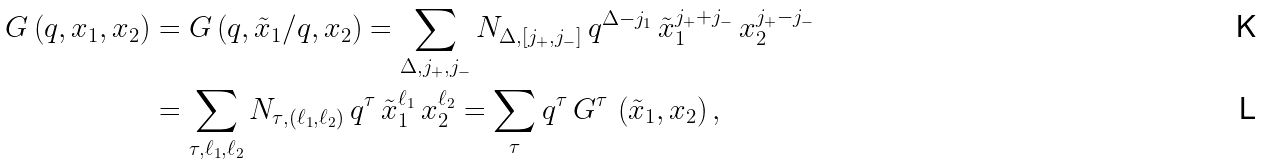<formula> <loc_0><loc_0><loc_500><loc_500>G \left ( q , x _ { 1 } , x _ { 2 } \right ) & = G \left ( q , \tilde { x } _ { 1 } / q , x _ { 2 } \right ) = \sum _ { \Delta , j _ { + } , j _ { - } } N _ { \Delta , [ j _ { + } , j _ { - } ] } \, q ^ { \Delta - j _ { 1 } } \, \tilde { x } _ { 1 } ^ { j _ { + } + j _ { - } } \, x _ { 2 } ^ { j _ { + } - j _ { - } } \\ & = \sum _ { \tau , \ell _ { 1 } , \ell _ { 2 } } N _ { \tau , ( \ell _ { 1 } , \ell _ { 2 } ) } \, q ^ { \tau } \, \tilde { x } _ { 1 } ^ { \ell _ { 1 } } \, x _ { 2 } ^ { \ell _ { 2 } } = \sum _ { \tau } q ^ { \tau } \, G ^ { \tau } \, \left ( \tilde { x } _ { 1 } , x _ { 2 } \right ) ,</formula> 